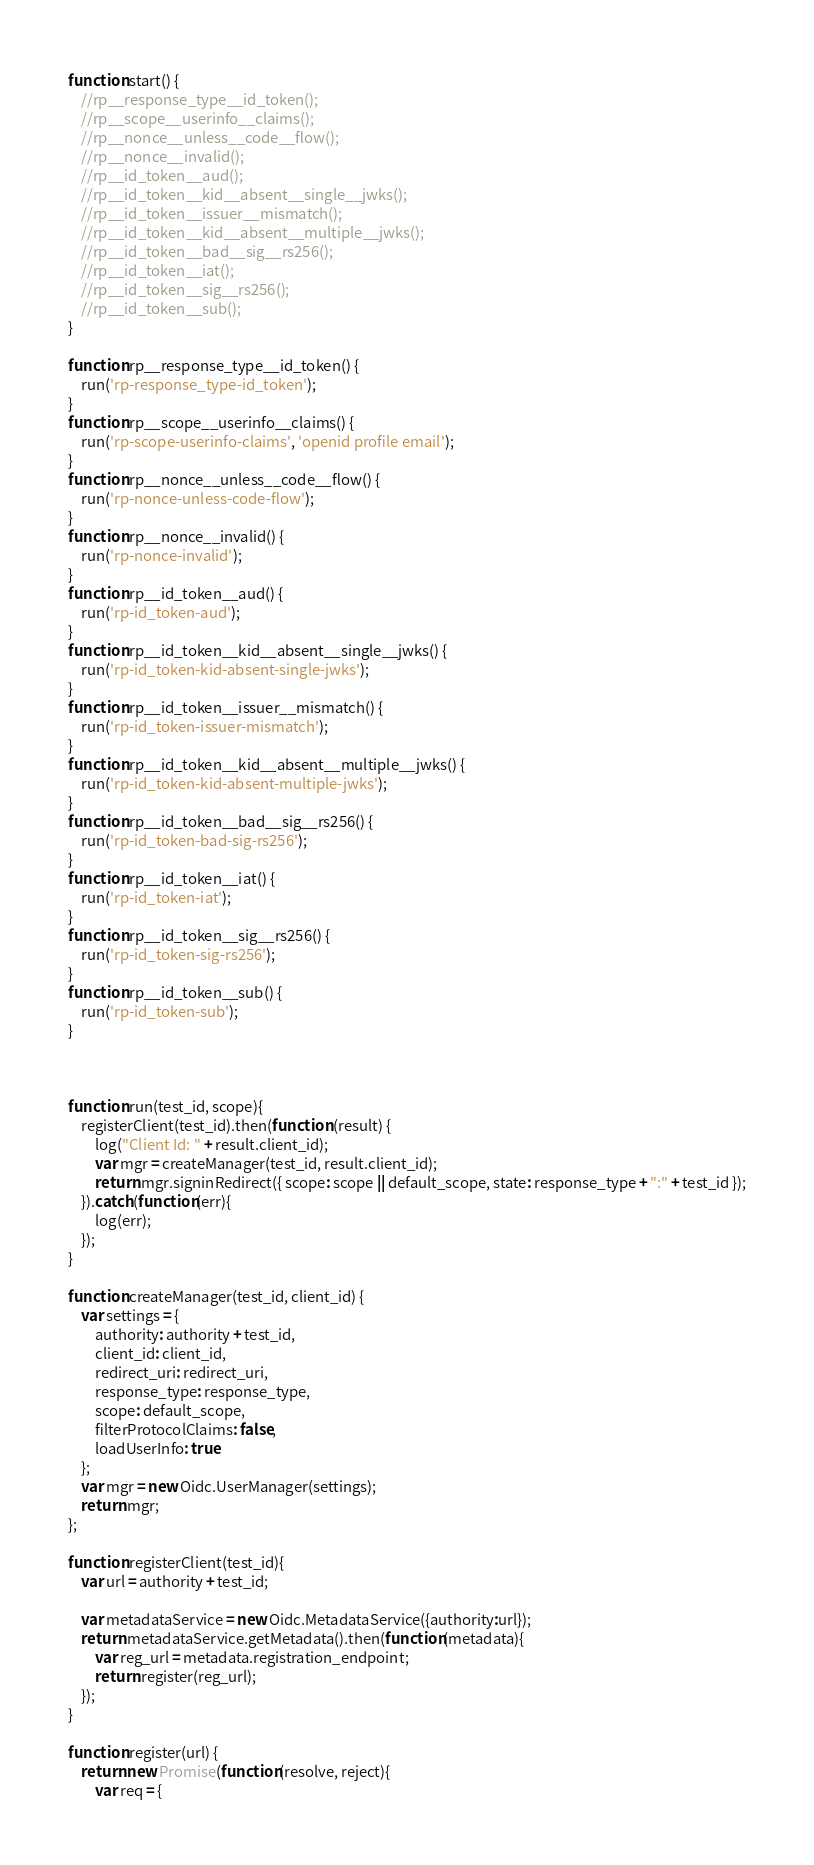<code> <loc_0><loc_0><loc_500><loc_500><_JavaScript_>function start() {
    //rp__response_type__id_token();
    //rp__scope__userinfo__claims();
    //rp__nonce__unless__code__flow();
    //rp__nonce__invalid();
    //rp__id_token__aud();
    //rp__id_token__kid__absent__single__jwks();
    //rp__id_token__issuer__mismatch();
    //rp__id_token__kid__absent__multiple__jwks();
    //rp__id_token__bad__sig__rs256();
    //rp__id_token__iat();
    //rp__id_token__sig__rs256();
    //rp__id_token__sub();
}

function rp__response_type__id_token() {
    run('rp-response_type-id_token');
}
function rp__scope__userinfo__claims() {
    run('rp-scope-userinfo-claims', 'openid profile email');
}
function rp__nonce__unless__code__flow() {
    run('rp-nonce-unless-code-flow');
}
function rp__nonce__invalid() {
    run('rp-nonce-invalid');
}
function rp__id_token__aud() {
    run('rp-id_token-aud');
}
function rp__id_token__kid__absent__single__jwks() {
    run('rp-id_token-kid-absent-single-jwks');
}
function rp__id_token__issuer__mismatch() {
    run('rp-id_token-issuer-mismatch');
}
function rp__id_token__kid__absent__multiple__jwks() {
    run('rp-id_token-kid-absent-multiple-jwks');
}
function rp__id_token__bad__sig__rs256() {
    run('rp-id_token-bad-sig-rs256');
}
function rp__id_token__iat() {
    run('rp-id_token-iat');
}
function rp__id_token__sig__rs256() {
    run('rp-id_token-sig-rs256');
}
function rp__id_token__sub() {
    run('rp-id_token-sub');
}



function run(test_id, scope){
    registerClient(test_id).then(function (result) {
        log("Client Id: " + result.client_id);
        var mgr = createManager(test_id, result.client_id);
        return mgr.signinRedirect({ scope: scope || default_scope, state: response_type + ":" + test_id });
    }).catch(function(err){
        log(err);
    });
}

function createManager(test_id, client_id) {
    var settings = {
        authority: authority + test_id,
        client_id: client_id,
        redirect_uri: redirect_uri,
        response_type: response_type,
        scope: default_scope,
        filterProtocolClaims: false,
        loadUserInfo: true
    };
    var mgr = new Oidc.UserManager(settings);
    return mgr;
};

function registerClient(test_id){
    var url = authority + test_id;

    var metadataService = new Oidc.MetadataService({authority:url});
    return metadataService.getMetadata().then(function(metadata){
        var reg_url = metadata.registration_endpoint;
        return register(reg_url);
    });
}

function register(url) {
    return new Promise(function(resolve, reject){
        var req = {</code> 